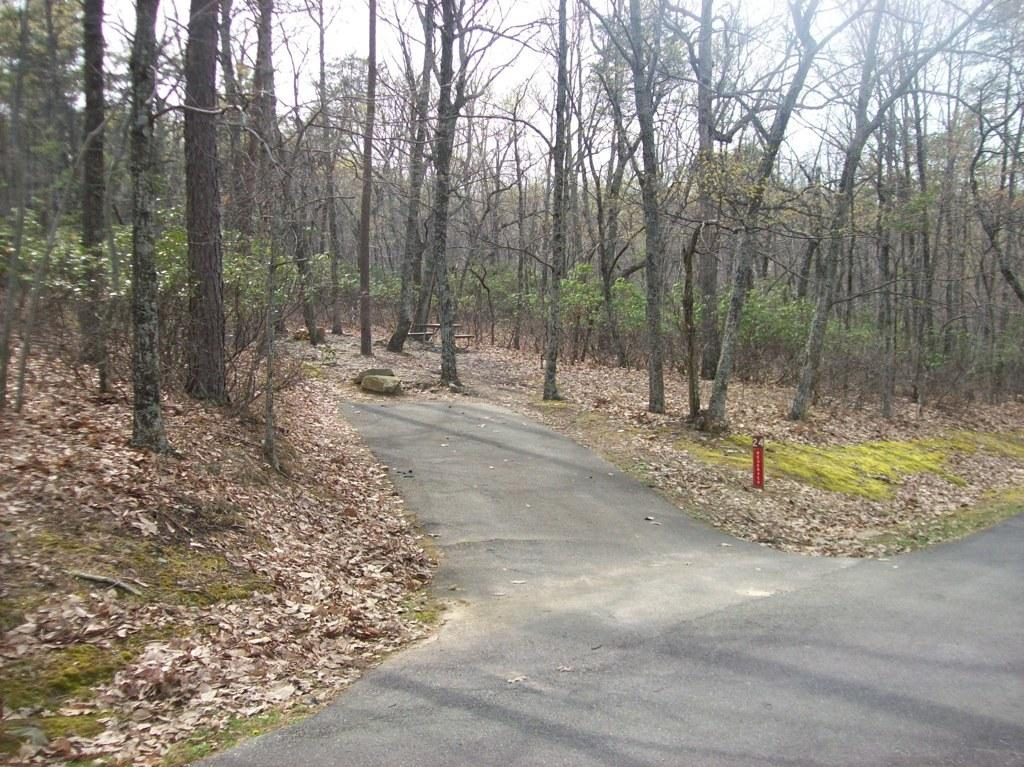What type of vegetation can be seen in the image? There are trees in the image. What can be seen running through the trees in the image? There is a road in the image. What is visible in the background of the image? The sky is visible in the background of the image. Can you tell me how many parents are protesting on the board in the image? There is no reference to parents, protest, or a board in the image. The image features trees, a road, and the sky. 